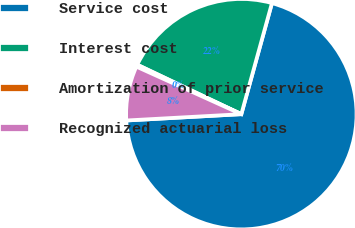<chart> <loc_0><loc_0><loc_500><loc_500><pie_chart><fcel>Service cost<fcel>Interest cost<fcel>Amortization of prior service<fcel>Recognized actuarial loss<nl><fcel>69.84%<fcel>22.22%<fcel>0.29%<fcel>7.64%<nl></chart> 